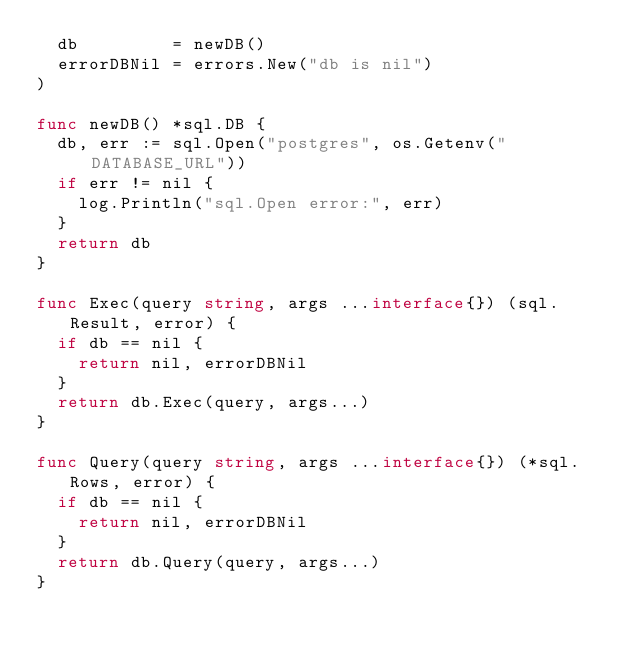Convert code to text. <code><loc_0><loc_0><loc_500><loc_500><_Go_>	db         = newDB()
	errorDBNil = errors.New("db is nil")
)

func newDB() *sql.DB {
	db, err := sql.Open("postgres", os.Getenv("DATABASE_URL"))
	if err != nil {
		log.Println("sql.Open error:", err)
	}
	return db
}

func Exec(query string, args ...interface{}) (sql.Result, error) {
	if db == nil {
		return nil, errorDBNil
	}
	return db.Exec(query, args...)
}

func Query(query string, args ...interface{}) (*sql.Rows, error) {
	if db == nil {
		return nil, errorDBNil
	}
	return db.Query(query, args...)
}
</code> 